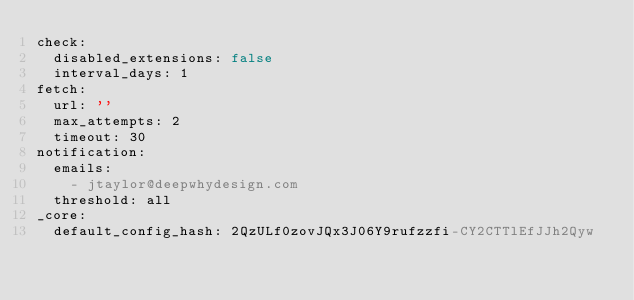Convert code to text. <code><loc_0><loc_0><loc_500><loc_500><_YAML_>check:
  disabled_extensions: false
  interval_days: 1
fetch:
  url: ''
  max_attempts: 2
  timeout: 30
notification:
  emails:
    - jtaylor@deepwhydesign.com
  threshold: all
_core:
  default_config_hash: 2QzULf0zovJQx3J06Y9rufzzfi-CY2CTTlEfJJh2Qyw
</code> 